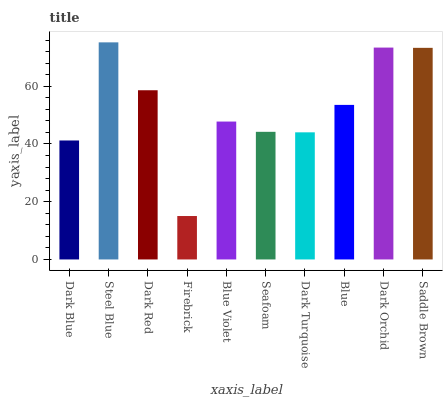Is Firebrick the minimum?
Answer yes or no. Yes. Is Steel Blue the maximum?
Answer yes or no. Yes. Is Dark Red the minimum?
Answer yes or no. No. Is Dark Red the maximum?
Answer yes or no. No. Is Steel Blue greater than Dark Red?
Answer yes or no. Yes. Is Dark Red less than Steel Blue?
Answer yes or no. Yes. Is Dark Red greater than Steel Blue?
Answer yes or no. No. Is Steel Blue less than Dark Red?
Answer yes or no. No. Is Blue the high median?
Answer yes or no. Yes. Is Blue Violet the low median?
Answer yes or no. Yes. Is Dark Red the high median?
Answer yes or no. No. Is Dark Orchid the low median?
Answer yes or no. No. 